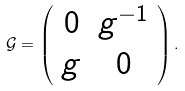<formula> <loc_0><loc_0><loc_500><loc_500>\mathcal { G } = \left ( \begin{array} { c c c } 0 & g ^ { - 1 } \\ g & 0 \\ \end{array} \right ) .</formula> 